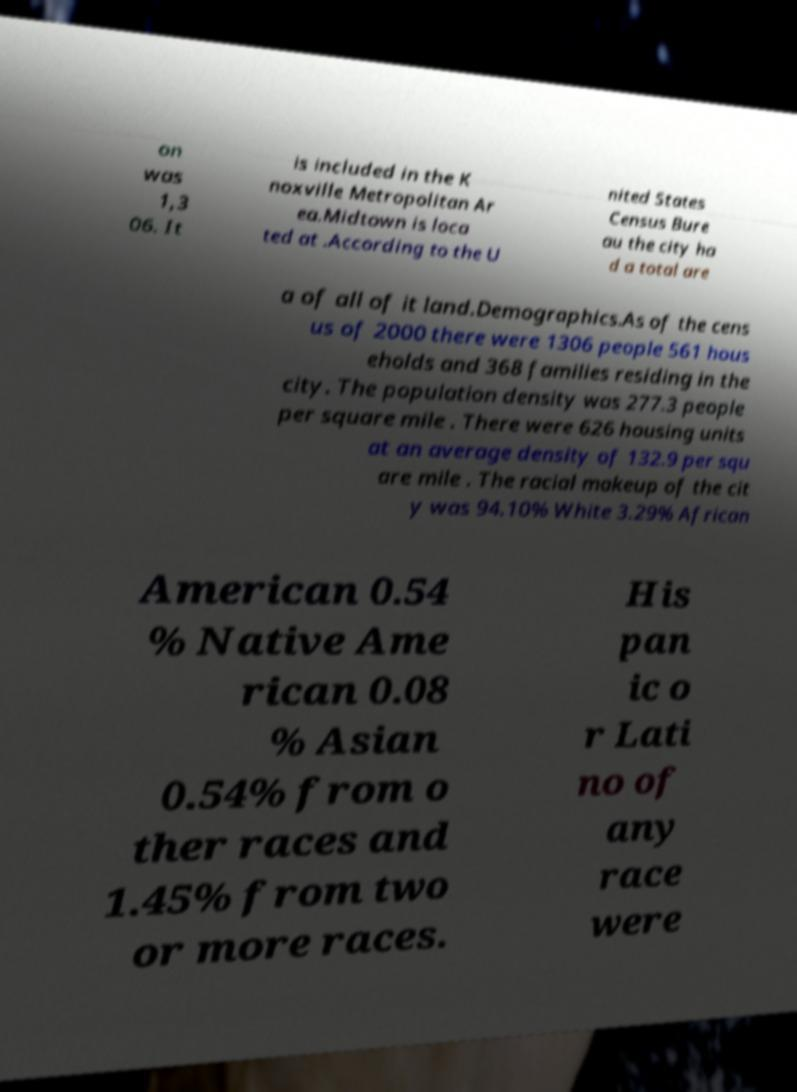There's text embedded in this image that I need extracted. Can you transcribe it verbatim? on was 1,3 06. It is included in the K noxville Metropolitan Ar ea.Midtown is loca ted at .According to the U nited States Census Bure au the city ha d a total are a of all of it land.Demographics.As of the cens us of 2000 there were 1306 people 561 hous eholds and 368 families residing in the city. The population density was 277.3 people per square mile . There were 626 housing units at an average density of 132.9 per squ are mile . The racial makeup of the cit y was 94.10% White 3.29% African American 0.54 % Native Ame rican 0.08 % Asian 0.54% from o ther races and 1.45% from two or more races. His pan ic o r Lati no of any race were 